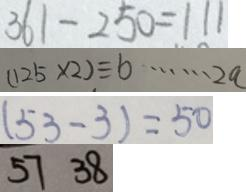<formula> <loc_0><loc_0><loc_500><loc_500>3 6 1 - 2 5 0 = 1 1 1 
 ( 1 2 5 \times 2 ) \div b \cdots 2 a 
 ( 5 3 - 3 ) = 5 0 
 5 7 3 8</formula> 